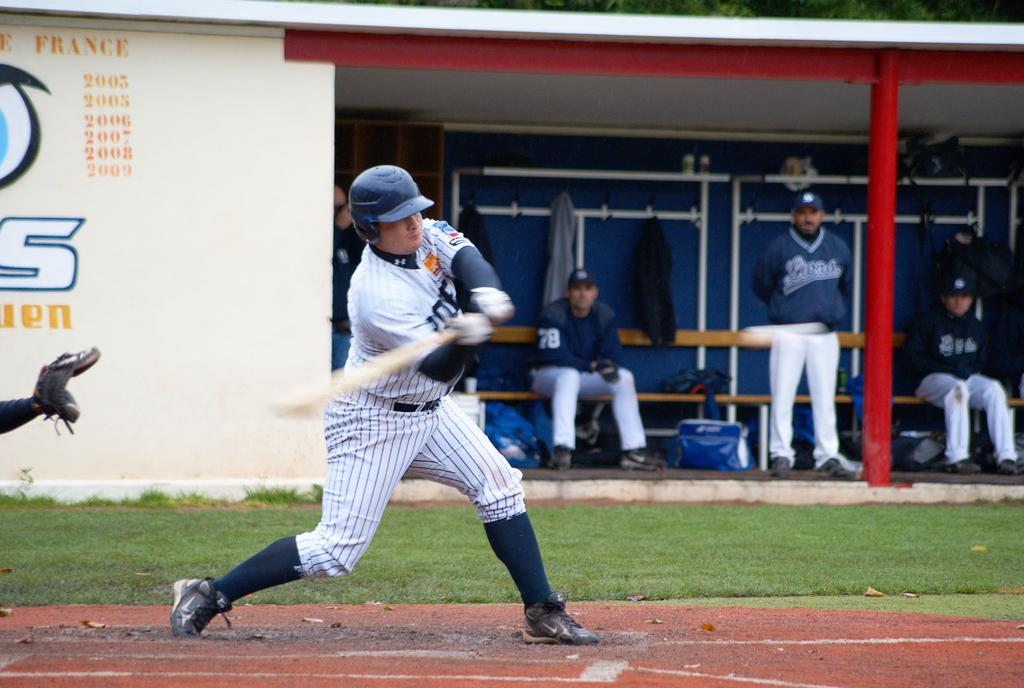<image>
Provide a brief description of the given image. A baseball players swings his bat in front of a wall that says France on it. 